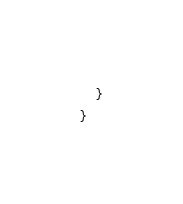<code> <loc_0><loc_0><loc_500><loc_500><_Kotlin_>    }
}
</code> 